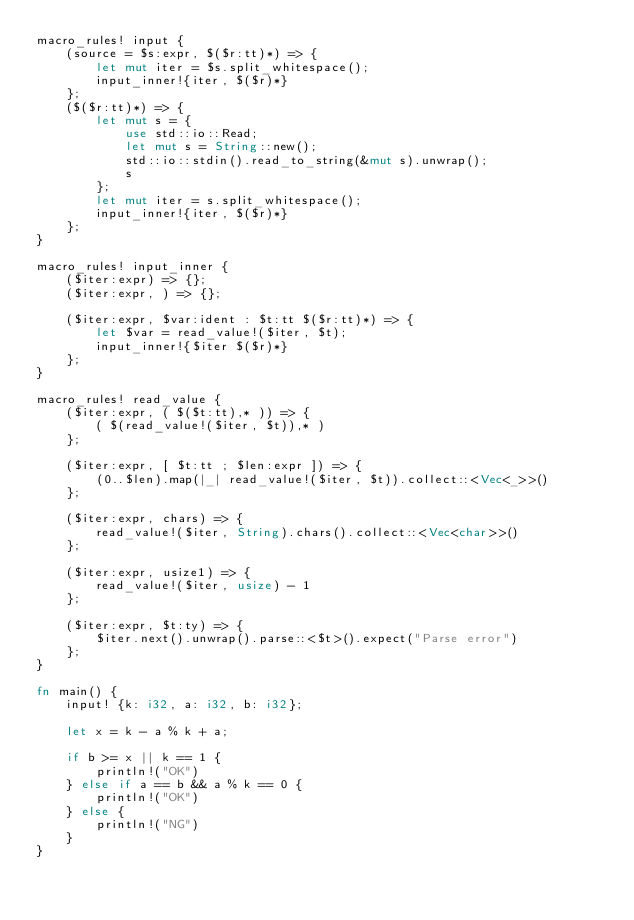Convert code to text. <code><loc_0><loc_0><loc_500><loc_500><_Rust_>macro_rules! input {
    (source = $s:expr, $($r:tt)*) => {
        let mut iter = $s.split_whitespace();
        input_inner!{iter, $($r)*}
    };
    ($($r:tt)*) => {
        let mut s = {
            use std::io::Read;
            let mut s = String::new();
            std::io::stdin().read_to_string(&mut s).unwrap();
            s
        };
        let mut iter = s.split_whitespace();
        input_inner!{iter, $($r)*}
    };
}

macro_rules! input_inner {
    ($iter:expr) => {};
    ($iter:expr, ) => {};

    ($iter:expr, $var:ident : $t:tt $($r:tt)*) => {
        let $var = read_value!($iter, $t);
        input_inner!{$iter $($r)*}
    };
}

macro_rules! read_value {
    ($iter:expr, ( $($t:tt),* )) => {
        ( $(read_value!($iter, $t)),* )
    };

    ($iter:expr, [ $t:tt ; $len:expr ]) => {
        (0..$len).map(|_| read_value!($iter, $t)).collect::<Vec<_>>()
    };

    ($iter:expr, chars) => {
        read_value!($iter, String).chars().collect::<Vec<char>>()
    };

    ($iter:expr, usize1) => {
        read_value!($iter, usize) - 1
    };

    ($iter:expr, $t:ty) => {
        $iter.next().unwrap().parse::<$t>().expect("Parse error")
    };
}

fn main() {
    input! {k: i32, a: i32, b: i32};

    let x = k - a % k + a;

    if b >= x || k == 1 {
        println!("OK")
    } else if a == b && a % k == 0 {
        println!("OK")
    } else {
        println!("NG")
    }
}
</code> 